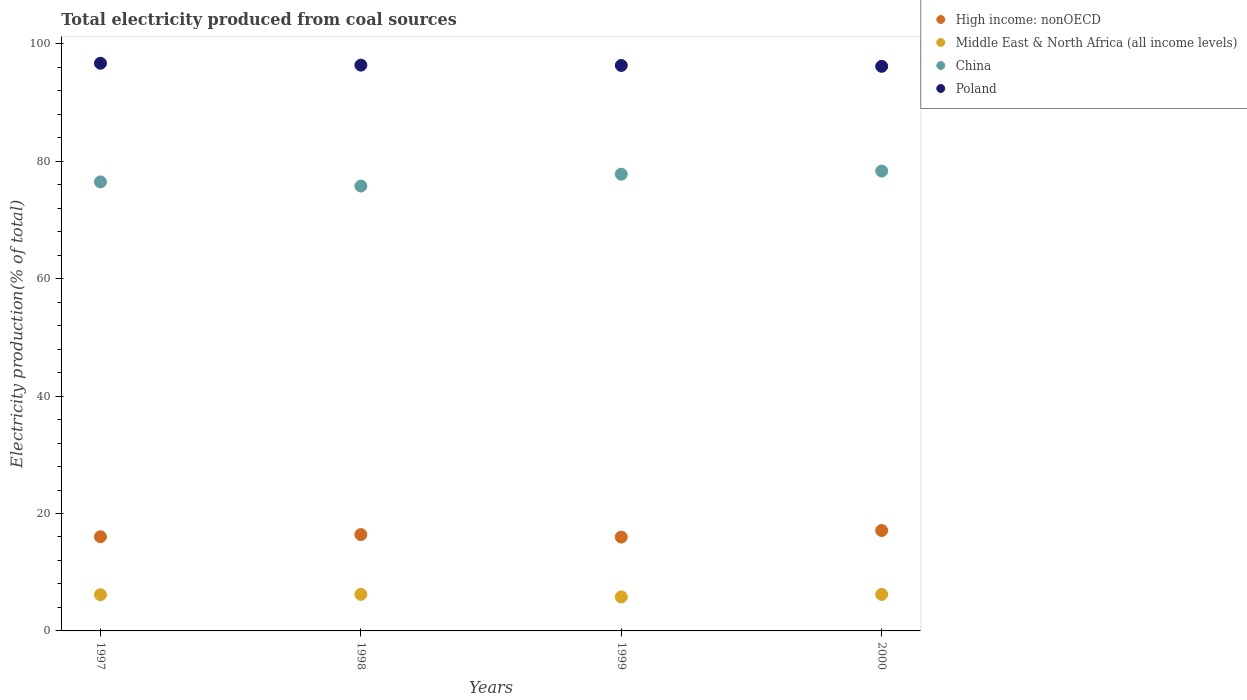Is the number of dotlines equal to the number of legend labels?
Your response must be concise. Yes. What is the total electricity produced in High income: nonOECD in 1997?
Your answer should be compact. 16.04. Across all years, what is the maximum total electricity produced in Middle East & North Africa (all income levels)?
Your answer should be compact. 6.23. Across all years, what is the minimum total electricity produced in Middle East & North Africa (all income levels)?
Keep it short and to the point. 5.79. In which year was the total electricity produced in High income: nonOECD minimum?
Keep it short and to the point. 1999. What is the total total electricity produced in High income: nonOECD in the graph?
Offer a terse response. 65.54. What is the difference between the total electricity produced in China in 1998 and that in 1999?
Your response must be concise. -2.02. What is the difference between the total electricity produced in Poland in 1997 and the total electricity produced in Middle East & North Africa (all income levels) in 2000?
Ensure brevity in your answer.  90.46. What is the average total electricity produced in Middle East & North Africa (all income levels) per year?
Provide a short and direct response. 6.1. In the year 2000, what is the difference between the total electricity produced in Middle East & North Africa (all income levels) and total electricity produced in Poland?
Keep it short and to the point. -89.94. What is the ratio of the total electricity produced in High income: nonOECD in 1998 to that in 1999?
Your response must be concise. 1.03. Is the total electricity produced in Middle East & North Africa (all income levels) in 1998 less than that in 2000?
Ensure brevity in your answer.  No. What is the difference between the highest and the second highest total electricity produced in Poland?
Ensure brevity in your answer.  0.32. What is the difference between the highest and the lowest total electricity produced in Poland?
Make the answer very short. 0.52. Is the sum of the total electricity produced in China in 1998 and 2000 greater than the maximum total electricity produced in Poland across all years?
Make the answer very short. Yes. Is it the case that in every year, the sum of the total electricity produced in China and total electricity produced in Middle East & North Africa (all income levels)  is greater than the sum of total electricity produced in Poland and total electricity produced in High income: nonOECD?
Keep it short and to the point. No. Is it the case that in every year, the sum of the total electricity produced in China and total electricity produced in High income: nonOECD  is greater than the total electricity produced in Middle East & North Africa (all income levels)?
Make the answer very short. Yes. How many years are there in the graph?
Offer a very short reply. 4. Are the values on the major ticks of Y-axis written in scientific E-notation?
Ensure brevity in your answer.  No. Where does the legend appear in the graph?
Give a very brief answer. Top right. How many legend labels are there?
Keep it short and to the point. 4. What is the title of the graph?
Provide a succinct answer. Total electricity produced from coal sources. Does "Ecuador" appear as one of the legend labels in the graph?
Provide a succinct answer. No. What is the Electricity production(% of total) in High income: nonOECD in 1997?
Your response must be concise. 16.04. What is the Electricity production(% of total) of Middle East & North Africa (all income levels) in 1997?
Your answer should be very brief. 6.17. What is the Electricity production(% of total) in China in 1997?
Offer a terse response. 76.47. What is the Electricity production(% of total) in Poland in 1997?
Give a very brief answer. 96.68. What is the Electricity production(% of total) of High income: nonOECD in 1998?
Your response must be concise. 16.41. What is the Electricity production(% of total) of Middle East & North Africa (all income levels) in 1998?
Your response must be concise. 6.23. What is the Electricity production(% of total) in China in 1998?
Provide a succinct answer. 75.77. What is the Electricity production(% of total) in Poland in 1998?
Your answer should be very brief. 96.36. What is the Electricity production(% of total) of High income: nonOECD in 1999?
Ensure brevity in your answer.  15.98. What is the Electricity production(% of total) of Middle East & North Africa (all income levels) in 1999?
Offer a terse response. 5.79. What is the Electricity production(% of total) in China in 1999?
Ensure brevity in your answer.  77.78. What is the Electricity production(% of total) in Poland in 1999?
Your answer should be very brief. 96.3. What is the Electricity production(% of total) in High income: nonOECD in 2000?
Your response must be concise. 17.11. What is the Electricity production(% of total) of Middle East & North Africa (all income levels) in 2000?
Provide a short and direct response. 6.22. What is the Electricity production(% of total) in China in 2000?
Ensure brevity in your answer.  78.32. What is the Electricity production(% of total) of Poland in 2000?
Your answer should be very brief. 96.15. Across all years, what is the maximum Electricity production(% of total) of High income: nonOECD?
Provide a short and direct response. 17.11. Across all years, what is the maximum Electricity production(% of total) in Middle East & North Africa (all income levels)?
Your answer should be compact. 6.23. Across all years, what is the maximum Electricity production(% of total) of China?
Ensure brevity in your answer.  78.32. Across all years, what is the maximum Electricity production(% of total) of Poland?
Your answer should be very brief. 96.68. Across all years, what is the minimum Electricity production(% of total) of High income: nonOECD?
Provide a short and direct response. 15.98. Across all years, what is the minimum Electricity production(% of total) in Middle East & North Africa (all income levels)?
Offer a very short reply. 5.79. Across all years, what is the minimum Electricity production(% of total) in China?
Offer a very short reply. 75.77. Across all years, what is the minimum Electricity production(% of total) in Poland?
Ensure brevity in your answer.  96.15. What is the total Electricity production(% of total) in High income: nonOECD in the graph?
Provide a succinct answer. 65.54. What is the total Electricity production(% of total) in Middle East & North Africa (all income levels) in the graph?
Keep it short and to the point. 24.4. What is the total Electricity production(% of total) of China in the graph?
Your response must be concise. 308.34. What is the total Electricity production(% of total) in Poland in the graph?
Make the answer very short. 385.49. What is the difference between the Electricity production(% of total) in High income: nonOECD in 1997 and that in 1998?
Provide a succinct answer. -0.37. What is the difference between the Electricity production(% of total) in Middle East & North Africa (all income levels) in 1997 and that in 1998?
Make the answer very short. -0.06. What is the difference between the Electricity production(% of total) in China in 1997 and that in 1998?
Keep it short and to the point. 0.71. What is the difference between the Electricity production(% of total) in Poland in 1997 and that in 1998?
Offer a very short reply. 0.32. What is the difference between the Electricity production(% of total) in High income: nonOECD in 1997 and that in 1999?
Offer a terse response. 0.06. What is the difference between the Electricity production(% of total) in Middle East & North Africa (all income levels) in 1997 and that in 1999?
Give a very brief answer. 0.38. What is the difference between the Electricity production(% of total) in China in 1997 and that in 1999?
Provide a succinct answer. -1.31. What is the difference between the Electricity production(% of total) of High income: nonOECD in 1997 and that in 2000?
Ensure brevity in your answer.  -1.07. What is the difference between the Electricity production(% of total) in Middle East & North Africa (all income levels) in 1997 and that in 2000?
Provide a succinct answer. -0.05. What is the difference between the Electricity production(% of total) of China in 1997 and that in 2000?
Give a very brief answer. -1.84. What is the difference between the Electricity production(% of total) of Poland in 1997 and that in 2000?
Ensure brevity in your answer.  0.52. What is the difference between the Electricity production(% of total) of High income: nonOECD in 1998 and that in 1999?
Keep it short and to the point. 0.43. What is the difference between the Electricity production(% of total) in Middle East & North Africa (all income levels) in 1998 and that in 1999?
Provide a succinct answer. 0.43. What is the difference between the Electricity production(% of total) in China in 1998 and that in 1999?
Your response must be concise. -2.02. What is the difference between the Electricity production(% of total) in Poland in 1998 and that in 1999?
Keep it short and to the point. 0.06. What is the difference between the Electricity production(% of total) of High income: nonOECD in 1998 and that in 2000?
Provide a succinct answer. -0.69. What is the difference between the Electricity production(% of total) in Middle East & North Africa (all income levels) in 1998 and that in 2000?
Your answer should be very brief. 0.01. What is the difference between the Electricity production(% of total) of China in 1998 and that in 2000?
Your answer should be very brief. -2.55. What is the difference between the Electricity production(% of total) in Poland in 1998 and that in 2000?
Offer a terse response. 0.21. What is the difference between the Electricity production(% of total) in High income: nonOECD in 1999 and that in 2000?
Your answer should be very brief. -1.12. What is the difference between the Electricity production(% of total) of Middle East & North Africa (all income levels) in 1999 and that in 2000?
Your answer should be very brief. -0.42. What is the difference between the Electricity production(% of total) of China in 1999 and that in 2000?
Offer a terse response. -0.53. What is the difference between the Electricity production(% of total) in Poland in 1999 and that in 2000?
Offer a very short reply. 0.15. What is the difference between the Electricity production(% of total) in High income: nonOECD in 1997 and the Electricity production(% of total) in Middle East & North Africa (all income levels) in 1998?
Give a very brief answer. 9.81. What is the difference between the Electricity production(% of total) in High income: nonOECD in 1997 and the Electricity production(% of total) in China in 1998?
Offer a very short reply. -59.73. What is the difference between the Electricity production(% of total) of High income: nonOECD in 1997 and the Electricity production(% of total) of Poland in 1998?
Your answer should be very brief. -80.32. What is the difference between the Electricity production(% of total) in Middle East & North Africa (all income levels) in 1997 and the Electricity production(% of total) in China in 1998?
Make the answer very short. -69.6. What is the difference between the Electricity production(% of total) of Middle East & North Africa (all income levels) in 1997 and the Electricity production(% of total) of Poland in 1998?
Keep it short and to the point. -90.19. What is the difference between the Electricity production(% of total) in China in 1997 and the Electricity production(% of total) in Poland in 1998?
Your answer should be very brief. -19.89. What is the difference between the Electricity production(% of total) in High income: nonOECD in 1997 and the Electricity production(% of total) in Middle East & North Africa (all income levels) in 1999?
Make the answer very short. 10.25. What is the difference between the Electricity production(% of total) of High income: nonOECD in 1997 and the Electricity production(% of total) of China in 1999?
Make the answer very short. -61.74. What is the difference between the Electricity production(% of total) of High income: nonOECD in 1997 and the Electricity production(% of total) of Poland in 1999?
Your answer should be very brief. -80.26. What is the difference between the Electricity production(% of total) of Middle East & North Africa (all income levels) in 1997 and the Electricity production(% of total) of China in 1999?
Offer a very short reply. -71.62. What is the difference between the Electricity production(% of total) in Middle East & North Africa (all income levels) in 1997 and the Electricity production(% of total) in Poland in 1999?
Your answer should be compact. -90.14. What is the difference between the Electricity production(% of total) in China in 1997 and the Electricity production(% of total) in Poland in 1999?
Make the answer very short. -19.83. What is the difference between the Electricity production(% of total) of High income: nonOECD in 1997 and the Electricity production(% of total) of Middle East & North Africa (all income levels) in 2000?
Provide a short and direct response. 9.82. What is the difference between the Electricity production(% of total) of High income: nonOECD in 1997 and the Electricity production(% of total) of China in 2000?
Provide a short and direct response. -62.28. What is the difference between the Electricity production(% of total) in High income: nonOECD in 1997 and the Electricity production(% of total) in Poland in 2000?
Offer a terse response. -80.11. What is the difference between the Electricity production(% of total) in Middle East & North Africa (all income levels) in 1997 and the Electricity production(% of total) in China in 2000?
Ensure brevity in your answer.  -72.15. What is the difference between the Electricity production(% of total) of Middle East & North Africa (all income levels) in 1997 and the Electricity production(% of total) of Poland in 2000?
Offer a very short reply. -89.99. What is the difference between the Electricity production(% of total) in China in 1997 and the Electricity production(% of total) in Poland in 2000?
Make the answer very short. -19.68. What is the difference between the Electricity production(% of total) of High income: nonOECD in 1998 and the Electricity production(% of total) of Middle East & North Africa (all income levels) in 1999?
Offer a terse response. 10.62. What is the difference between the Electricity production(% of total) in High income: nonOECD in 1998 and the Electricity production(% of total) in China in 1999?
Ensure brevity in your answer.  -61.37. What is the difference between the Electricity production(% of total) of High income: nonOECD in 1998 and the Electricity production(% of total) of Poland in 1999?
Ensure brevity in your answer.  -79.89. What is the difference between the Electricity production(% of total) in Middle East & North Africa (all income levels) in 1998 and the Electricity production(% of total) in China in 1999?
Offer a very short reply. -71.56. What is the difference between the Electricity production(% of total) of Middle East & North Africa (all income levels) in 1998 and the Electricity production(% of total) of Poland in 1999?
Offer a terse response. -90.08. What is the difference between the Electricity production(% of total) of China in 1998 and the Electricity production(% of total) of Poland in 1999?
Ensure brevity in your answer.  -20.53. What is the difference between the Electricity production(% of total) in High income: nonOECD in 1998 and the Electricity production(% of total) in Middle East & North Africa (all income levels) in 2000?
Your answer should be very brief. 10.19. What is the difference between the Electricity production(% of total) in High income: nonOECD in 1998 and the Electricity production(% of total) in China in 2000?
Offer a very short reply. -61.91. What is the difference between the Electricity production(% of total) of High income: nonOECD in 1998 and the Electricity production(% of total) of Poland in 2000?
Keep it short and to the point. -79.74. What is the difference between the Electricity production(% of total) of Middle East & North Africa (all income levels) in 1998 and the Electricity production(% of total) of China in 2000?
Your answer should be very brief. -72.09. What is the difference between the Electricity production(% of total) of Middle East & North Africa (all income levels) in 1998 and the Electricity production(% of total) of Poland in 2000?
Offer a terse response. -89.93. What is the difference between the Electricity production(% of total) in China in 1998 and the Electricity production(% of total) in Poland in 2000?
Offer a very short reply. -20.38. What is the difference between the Electricity production(% of total) in High income: nonOECD in 1999 and the Electricity production(% of total) in Middle East & North Africa (all income levels) in 2000?
Your answer should be very brief. 9.77. What is the difference between the Electricity production(% of total) of High income: nonOECD in 1999 and the Electricity production(% of total) of China in 2000?
Offer a very short reply. -62.33. What is the difference between the Electricity production(% of total) in High income: nonOECD in 1999 and the Electricity production(% of total) in Poland in 2000?
Give a very brief answer. -80.17. What is the difference between the Electricity production(% of total) in Middle East & North Africa (all income levels) in 1999 and the Electricity production(% of total) in China in 2000?
Offer a terse response. -72.52. What is the difference between the Electricity production(% of total) in Middle East & North Africa (all income levels) in 1999 and the Electricity production(% of total) in Poland in 2000?
Make the answer very short. -90.36. What is the difference between the Electricity production(% of total) in China in 1999 and the Electricity production(% of total) in Poland in 2000?
Make the answer very short. -18.37. What is the average Electricity production(% of total) of High income: nonOECD per year?
Your answer should be very brief. 16.38. What is the average Electricity production(% of total) of Middle East & North Africa (all income levels) per year?
Offer a terse response. 6.1. What is the average Electricity production(% of total) of China per year?
Offer a very short reply. 77.09. What is the average Electricity production(% of total) in Poland per year?
Your answer should be very brief. 96.37. In the year 1997, what is the difference between the Electricity production(% of total) of High income: nonOECD and Electricity production(% of total) of Middle East & North Africa (all income levels)?
Offer a terse response. 9.87. In the year 1997, what is the difference between the Electricity production(% of total) of High income: nonOECD and Electricity production(% of total) of China?
Provide a succinct answer. -60.43. In the year 1997, what is the difference between the Electricity production(% of total) in High income: nonOECD and Electricity production(% of total) in Poland?
Provide a short and direct response. -80.64. In the year 1997, what is the difference between the Electricity production(% of total) in Middle East & North Africa (all income levels) and Electricity production(% of total) in China?
Your answer should be compact. -70.31. In the year 1997, what is the difference between the Electricity production(% of total) in Middle East & North Africa (all income levels) and Electricity production(% of total) in Poland?
Your response must be concise. -90.51. In the year 1997, what is the difference between the Electricity production(% of total) of China and Electricity production(% of total) of Poland?
Your response must be concise. -20.2. In the year 1998, what is the difference between the Electricity production(% of total) of High income: nonOECD and Electricity production(% of total) of Middle East & North Africa (all income levels)?
Give a very brief answer. 10.18. In the year 1998, what is the difference between the Electricity production(% of total) in High income: nonOECD and Electricity production(% of total) in China?
Your answer should be very brief. -59.36. In the year 1998, what is the difference between the Electricity production(% of total) of High income: nonOECD and Electricity production(% of total) of Poland?
Your answer should be very brief. -79.95. In the year 1998, what is the difference between the Electricity production(% of total) of Middle East & North Africa (all income levels) and Electricity production(% of total) of China?
Ensure brevity in your answer.  -69.54. In the year 1998, what is the difference between the Electricity production(% of total) of Middle East & North Africa (all income levels) and Electricity production(% of total) of Poland?
Provide a short and direct response. -90.13. In the year 1998, what is the difference between the Electricity production(% of total) in China and Electricity production(% of total) in Poland?
Your answer should be very brief. -20.59. In the year 1999, what is the difference between the Electricity production(% of total) of High income: nonOECD and Electricity production(% of total) of Middle East & North Africa (all income levels)?
Your answer should be compact. 10.19. In the year 1999, what is the difference between the Electricity production(% of total) in High income: nonOECD and Electricity production(% of total) in China?
Your response must be concise. -61.8. In the year 1999, what is the difference between the Electricity production(% of total) of High income: nonOECD and Electricity production(% of total) of Poland?
Offer a very short reply. -80.32. In the year 1999, what is the difference between the Electricity production(% of total) of Middle East & North Africa (all income levels) and Electricity production(% of total) of China?
Ensure brevity in your answer.  -71.99. In the year 1999, what is the difference between the Electricity production(% of total) of Middle East & North Africa (all income levels) and Electricity production(% of total) of Poland?
Make the answer very short. -90.51. In the year 1999, what is the difference between the Electricity production(% of total) of China and Electricity production(% of total) of Poland?
Your answer should be compact. -18.52. In the year 2000, what is the difference between the Electricity production(% of total) in High income: nonOECD and Electricity production(% of total) in Middle East & North Africa (all income levels)?
Keep it short and to the point. 10.89. In the year 2000, what is the difference between the Electricity production(% of total) of High income: nonOECD and Electricity production(% of total) of China?
Provide a short and direct response. -61.21. In the year 2000, what is the difference between the Electricity production(% of total) in High income: nonOECD and Electricity production(% of total) in Poland?
Your answer should be very brief. -79.05. In the year 2000, what is the difference between the Electricity production(% of total) in Middle East & North Africa (all income levels) and Electricity production(% of total) in China?
Offer a terse response. -72.1. In the year 2000, what is the difference between the Electricity production(% of total) in Middle East & North Africa (all income levels) and Electricity production(% of total) in Poland?
Keep it short and to the point. -89.94. In the year 2000, what is the difference between the Electricity production(% of total) in China and Electricity production(% of total) in Poland?
Provide a short and direct response. -17.84. What is the ratio of the Electricity production(% of total) in High income: nonOECD in 1997 to that in 1998?
Your answer should be compact. 0.98. What is the ratio of the Electricity production(% of total) in China in 1997 to that in 1998?
Provide a short and direct response. 1.01. What is the ratio of the Electricity production(% of total) of High income: nonOECD in 1997 to that in 1999?
Give a very brief answer. 1. What is the ratio of the Electricity production(% of total) in Middle East & North Africa (all income levels) in 1997 to that in 1999?
Make the answer very short. 1.06. What is the ratio of the Electricity production(% of total) in China in 1997 to that in 1999?
Your answer should be compact. 0.98. What is the ratio of the Electricity production(% of total) of Poland in 1997 to that in 1999?
Your answer should be compact. 1. What is the ratio of the Electricity production(% of total) in High income: nonOECD in 1997 to that in 2000?
Provide a short and direct response. 0.94. What is the ratio of the Electricity production(% of total) in China in 1997 to that in 2000?
Your response must be concise. 0.98. What is the ratio of the Electricity production(% of total) of Poland in 1997 to that in 2000?
Ensure brevity in your answer.  1.01. What is the ratio of the Electricity production(% of total) of High income: nonOECD in 1998 to that in 1999?
Your answer should be compact. 1.03. What is the ratio of the Electricity production(% of total) in Middle East & North Africa (all income levels) in 1998 to that in 1999?
Ensure brevity in your answer.  1.07. What is the ratio of the Electricity production(% of total) in China in 1998 to that in 1999?
Your answer should be compact. 0.97. What is the ratio of the Electricity production(% of total) in High income: nonOECD in 1998 to that in 2000?
Provide a succinct answer. 0.96. What is the ratio of the Electricity production(% of total) in Middle East & North Africa (all income levels) in 1998 to that in 2000?
Offer a very short reply. 1. What is the ratio of the Electricity production(% of total) of China in 1998 to that in 2000?
Give a very brief answer. 0.97. What is the ratio of the Electricity production(% of total) of High income: nonOECD in 1999 to that in 2000?
Keep it short and to the point. 0.93. What is the ratio of the Electricity production(% of total) in Middle East & North Africa (all income levels) in 1999 to that in 2000?
Ensure brevity in your answer.  0.93. What is the ratio of the Electricity production(% of total) of China in 1999 to that in 2000?
Give a very brief answer. 0.99. What is the ratio of the Electricity production(% of total) of Poland in 1999 to that in 2000?
Your answer should be very brief. 1. What is the difference between the highest and the second highest Electricity production(% of total) of High income: nonOECD?
Give a very brief answer. 0.69. What is the difference between the highest and the second highest Electricity production(% of total) in Middle East & North Africa (all income levels)?
Make the answer very short. 0.01. What is the difference between the highest and the second highest Electricity production(% of total) in China?
Your answer should be very brief. 0.53. What is the difference between the highest and the second highest Electricity production(% of total) in Poland?
Provide a succinct answer. 0.32. What is the difference between the highest and the lowest Electricity production(% of total) in High income: nonOECD?
Ensure brevity in your answer.  1.12. What is the difference between the highest and the lowest Electricity production(% of total) in Middle East & North Africa (all income levels)?
Your answer should be very brief. 0.43. What is the difference between the highest and the lowest Electricity production(% of total) in China?
Your answer should be compact. 2.55. What is the difference between the highest and the lowest Electricity production(% of total) of Poland?
Offer a very short reply. 0.52. 